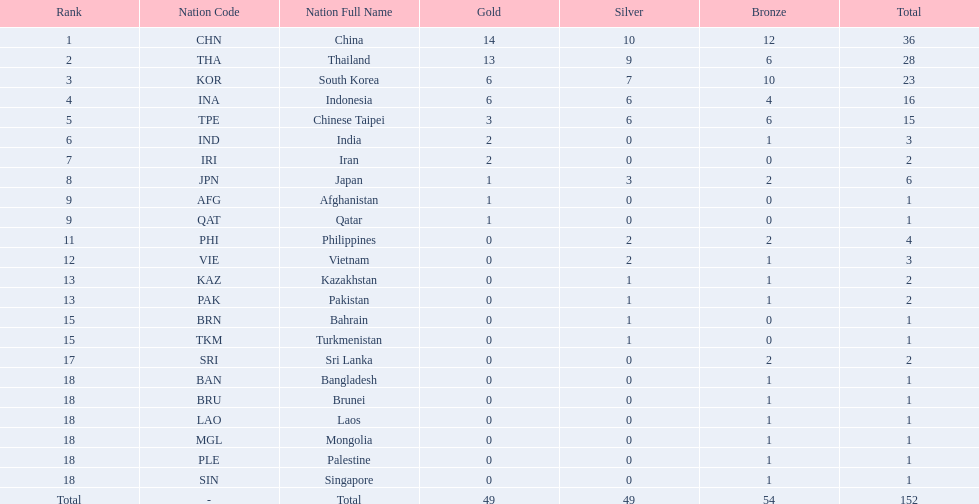How many more medals did india earn compared to pakistan? 1. 